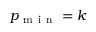Convert formula to latex. <formula><loc_0><loc_0><loc_500><loc_500>p _ { m i n } = k</formula> 